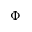<formula> <loc_0><loc_0><loc_500><loc_500>\Phi</formula> 